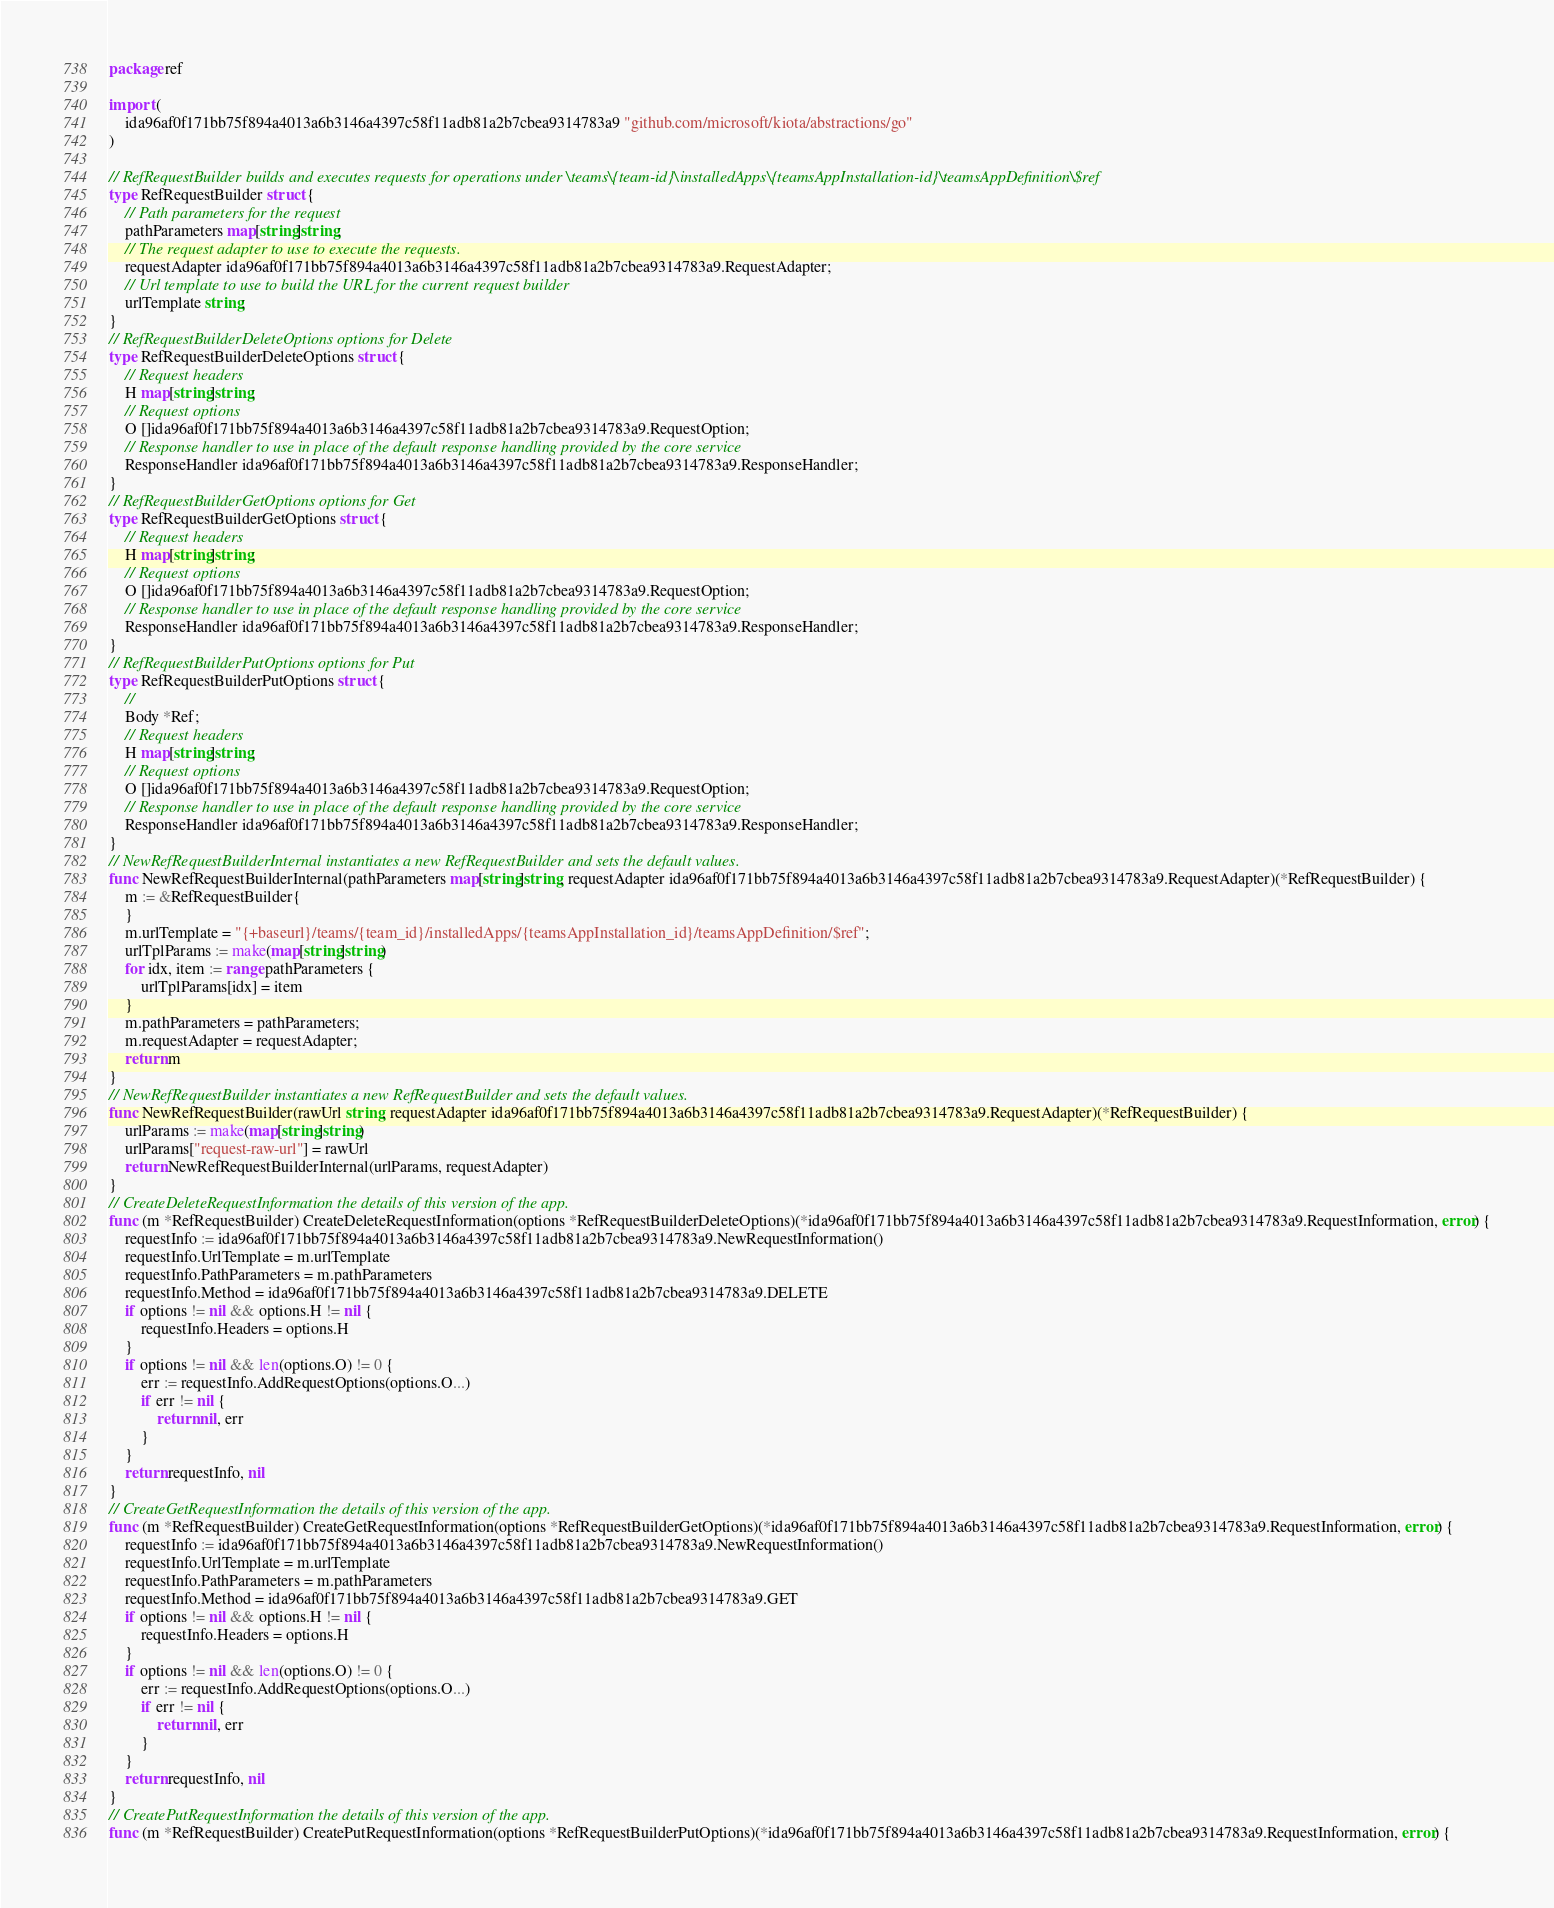Convert code to text. <code><loc_0><loc_0><loc_500><loc_500><_Go_>package ref

import (
    ida96af0f171bb75f894a4013a6b3146a4397c58f11adb81a2b7cbea9314783a9 "github.com/microsoft/kiota/abstractions/go"
)

// RefRequestBuilder builds and executes requests for operations under \teams\{team-id}\installedApps\{teamsAppInstallation-id}\teamsAppDefinition\$ref
type RefRequestBuilder struct {
    // Path parameters for the request
    pathParameters map[string]string;
    // The request adapter to use to execute the requests.
    requestAdapter ida96af0f171bb75f894a4013a6b3146a4397c58f11adb81a2b7cbea9314783a9.RequestAdapter;
    // Url template to use to build the URL for the current request builder
    urlTemplate string;
}
// RefRequestBuilderDeleteOptions options for Delete
type RefRequestBuilderDeleteOptions struct {
    // Request headers
    H map[string]string;
    // Request options
    O []ida96af0f171bb75f894a4013a6b3146a4397c58f11adb81a2b7cbea9314783a9.RequestOption;
    // Response handler to use in place of the default response handling provided by the core service
    ResponseHandler ida96af0f171bb75f894a4013a6b3146a4397c58f11adb81a2b7cbea9314783a9.ResponseHandler;
}
// RefRequestBuilderGetOptions options for Get
type RefRequestBuilderGetOptions struct {
    // Request headers
    H map[string]string;
    // Request options
    O []ida96af0f171bb75f894a4013a6b3146a4397c58f11adb81a2b7cbea9314783a9.RequestOption;
    // Response handler to use in place of the default response handling provided by the core service
    ResponseHandler ida96af0f171bb75f894a4013a6b3146a4397c58f11adb81a2b7cbea9314783a9.ResponseHandler;
}
// RefRequestBuilderPutOptions options for Put
type RefRequestBuilderPutOptions struct {
    // 
    Body *Ref;
    // Request headers
    H map[string]string;
    // Request options
    O []ida96af0f171bb75f894a4013a6b3146a4397c58f11adb81a2b7cbea9314783a9.RequestOption;
    // Response handler to use in place of the default response handling provided by the core service
    ResponseHandler ida96af0f171bb75f894a4013a6b3146a4397c58f11adb81a2b7cbea9314783a9.ResponseHandler;
}
// NewRefRequestBuilderInternal instantiates a new RefRequestBuilder and sets the default values.
func NewRefRequestBuilderInternal(pathParameters map[string]string, requestAdapter ida96af0f171bb75f894a4013a6b3146a4397c58f11adb81a2b7cbea9314783a9.RequestAdapter)(*RefRequestBuilder) {
    m := &RefRequestBuilder{
    }
    m.urlTemplate = "{+baseurl}/teams/{team_id}/installedApps/{teamsAppInstallation_id}/teamsAppDefinition/$ref";
    urlTplParams := make(map[string]string)
    for idx, item := range pathParameters {
        urlTplParams[idx] = item
    }
    m.pathParameters = pathParameters;
    m.requestAdapter = requestAdapter;
    return m
}
// NewRefRequestBuilder instantiates a new RefRequestBuilder and sets the default values.
func NewRefRequestBuilder(rawUrl string, requestAdapter ida96af0f171bb75f894a4013a6b3146a4397c58f11adb81a2b7cbea9314783a9.RequestAdapter)(*RefRequestBuilder) {
    urlParams := make(map[string]string)
    urlParams["request-raw-url"] = rawUrl
    return NewRefRequestBuilderInternal(urlParams, requestAdapter)
}
// CreateDeleteRequestInformation the details of this version of the app.
func (m *RefRequestBuilder) CreateDeleteRequestInformation(options *RefRequestBuilderDeleteOptions)(*ida96af0f171bb75f894a4013a6b3146a4397c58f11adb81a2b7cbea9314783a9.RequestInformation, error) {
    requestInfo := ida96af0f171bb75f894a4013a6b3146a4397c58f11adb81a2b7cbea9314783a9.NewRequestInformation()
    requestInfo.UrlTemplate = m.urlTemplate
    requestInfo.PathParameters = m.pathParameters
    requestInfo.Method = ida96af0f171bb75f894a4013a6b3146a4397c58f11adb81a2b7cbea9314783a9.DELETE
    if options != nil && options.H != nil {
        requestInfo.Headers = options.H
    }
    if options != nil && len(options.O) != 0 {
        err := requestInfo.AddRequestOptions(options.O...)
        if err != nil {
            return nil, err
        }
    }
    return requestInfo, nil
}
// CreateGetRequestInformation the details of this version of the app.
func (m *RefRequestBuilder) CreateGetRequestInformation(options *RefRequestBuilderGetOptions)(*ida96af0f171bb75f894a4013a6b3146a4397c58f11adb81a2b7cbea9314783a9.RequestInformation, error) {
    requestInfo := ida96af0f171bb75f894a4013a6b3146a4397c58f11adb81a2b7cbea9314783a9.NewRequestInformation()
    requestInfo.UrlTemplate = m.urlTemplate
    requestInfo.PathParameters = m.pathParameters
    requestInfo.Method = ida96af0f171bb75f894a4013a6b3146a4397c58f11adb81a2b7cbea9314783a9.GET
    if options != nil && options.H != nil {
        requestInfo.Headers = options.H
    }
    if options != nil && len(options.O) != 0 {
        err := requestInfo.AddRequestOptions(options.O...)
        if err != nil {
            return nil, err
        }
    }
    return requestInfo, nil
}
// CreatePutRequestInformation the details of this version of the app.
func (m *RefRequestBuilder) CreatePutRequestInformation(options *RefRequestBuilderPutOptions)(*ida96af0f171bb75f894a4013a6b3146a4397c58f11adb81a2b7cbea9314783a9.RequestInformation, error) {</code> 